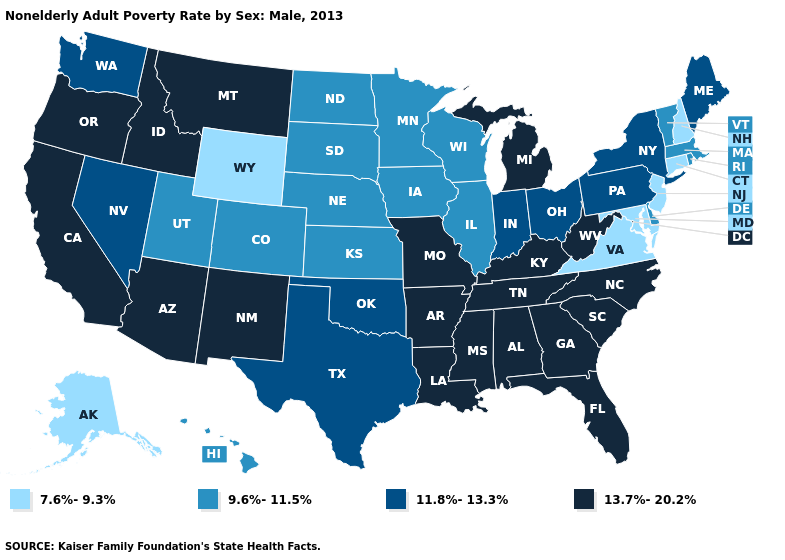What is the lowest value in the MidWest?
Write a very short answer. 9.6%-11.5%. Is the legend a continuous bar?
Quick response, please. No. What is the value of Indiana?
Keep it brief. 11.8%-13.3%. What is the lowest value in states that border California?
Short answer required. 11.8%-13.3%. What is the value of Utah?
Short answer required. 9.6%-11.5%. Does Ohio have the lowest value in the USA?
Write a very short answer. No. How many symbols are there in the legend?
Write a very short answer. 4. Does the first symbol in the legend represent the smallest category?
Concise answer only. Yes. What is the value of South Dakota?
Keep it brief. 9.6%-11.5%. Name the states that have a value in the range 9.6%-11.5%?
Keep it brief. Colorado, Delaware, Hawaii, Illinois, Iowa, Kansas, Massachusetts, Minnesota, Nebraska, North Dakota, Rhode Island, South Dakota, Utah, Vermont, Wisconsin. Does the first symbol in the legend represent the smallest category?
Write a very short answer. Yes. Does Arkansas have the highest value in the South?
Concise answer only. Yes. What is the highest value in the USA?
Quick response, please. 13.7%-20.2%. 